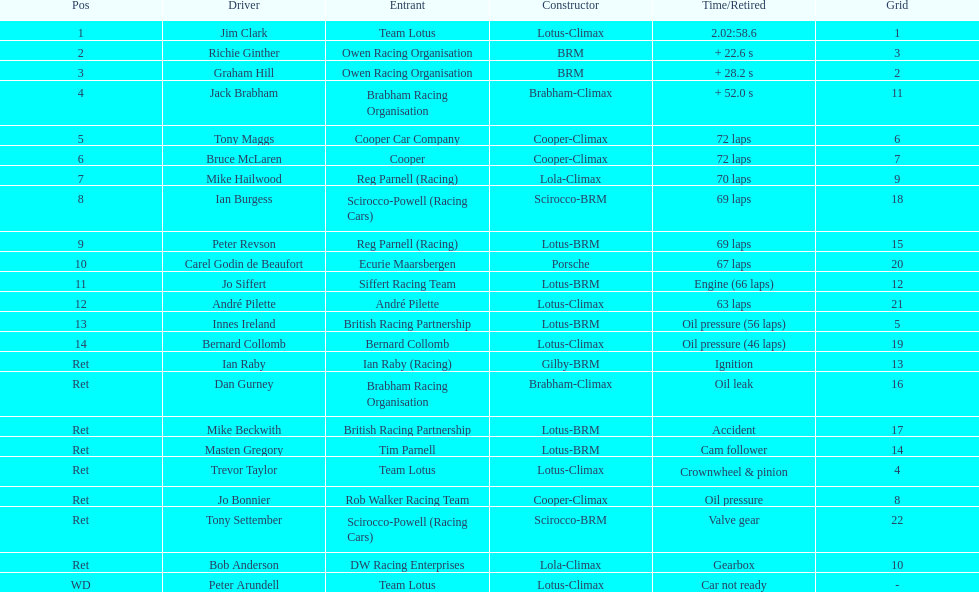What is the quantity of americans present in the top 5? 1. 